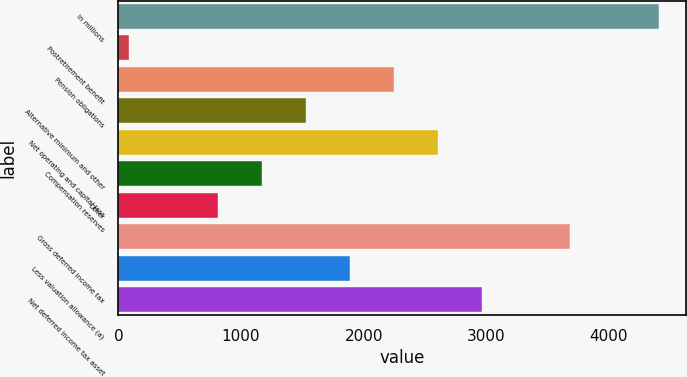Convert chart. <chart><loc_0><loc_0><loc_500><loc_500><bar_chart><fcel>In millions<fcel>Postretirement benefit<fcel>Pension obligations<fcel>Alternative minimum and other<fcel>Net operating and capital loss<fcel>Compensation reserves<fcel>Other<fcel>Gross deferred income tax<fcel>Less valuation allowance (a)<fcel>Net deferred income tax asset<nl><fcel>4405.4<fcel>89<fcel>2247.2<fcel>1527.8<fcel>2606.9<fcel>1168.1<fcel>808.4<fcel>3686<fcel>1887.5<fcel>2966.6<nl></chart> 